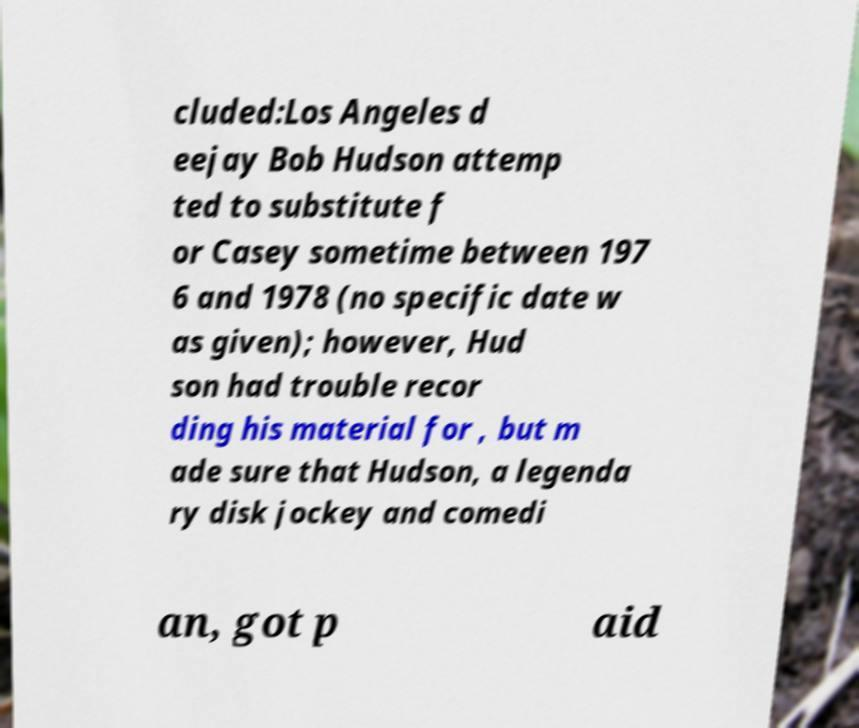I need the written content from this picture converted into text. Can you do that? cluded:Los Angeles d eejay Bob Hudson attemp ted to substitute f or Casey sometime between 197 6 and 1978 (no specific date w as given); however, Hud son had trouble recor ding his material for , but m ade sure that Hudson, a legenda ry disk jockey and comedi an, got p aid 